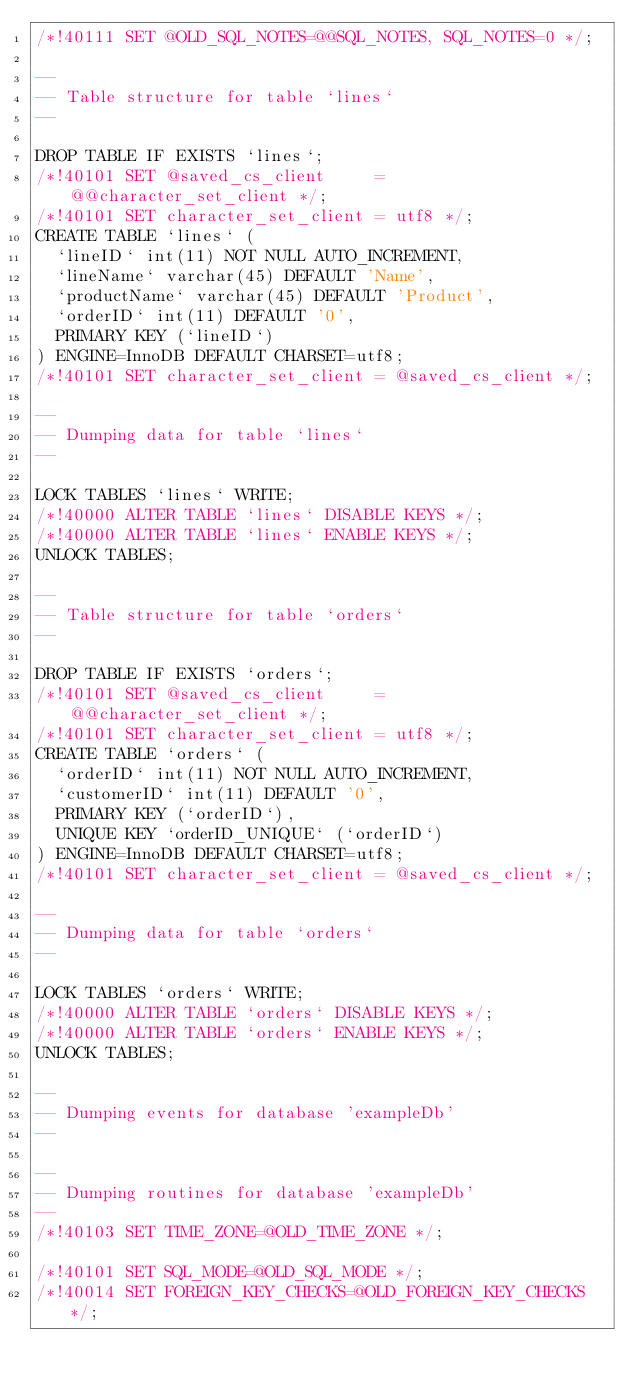Convert code to text. <code><loc_0><loc_0><loc_500><loc_500><_SQL_>/*!40111 SET @OLD_SQL_NOTES=@@SQL_NOTES, SQL_NOTES=0 */;

--
-- Table structure for table `lines`
--

DROP TABLE IF EXISTS `lines`;
/*!40101 SET @saved_cs_client     = @@character_set_client */;
/*!40101 SET character_set_client = utf8 */;
CREATE TABLE `lines` (
  `lineID` int(11) NOT NULL AUTO_INCREMENT,
  `lineName` varchar(45) DEFAULT 'Name',
  `productName` varchar(45) DEFAULT 'Product',
  `orderID` int(11) DEFAULT '0',
  PRIMARY KEY (`lineID`)
) ENGINE=InnoDB DEFAULT CHARSET=utf8;
/*!40101 SET character_set_client = @saved_cs_client */;

--
-- Dumping data for table `lines`
--

LOCK TABLES `lines` WRITE;
/*!40000 ALTER TABLE `lines` DISABLE KEYS */;
/*!40000 ALTER TABLE `lines` ENABLE KEYS */;
UNLOCK TABLES;

--
-- Table structure for table `orders`
--

DROP TABLE IF EXISTS `orders`;
/*!40101 SET @saved_cs_client     = @@character_set_client */;
/*!40101 SET character_set_client = utf8 */;
CREATE TABLE `orders` (
  `orderID` int(11) NOT NULL AUTO_INCREMENT,
  `customerID` int(11) DEFAULT '0',
  PRIMARY KEY (`orderID`),
  UNIQUE KEY `orderID_UNIQUE` (`orderID`)
) ENGINE=InnoDB DEFAULT CHARSET=utf8;
/*!40101 SET character_set_client = @saved_cs_client */;

--
-- Dumping data for table `orders`
--

LOCK TABLES `orders` WRITE;
/*!40000 ALTER TABLE `orders` DISABLE KEYS */;
/*!40000 ALTER TABLE `orders` ENABLE KEYS */;
UNLOCK TABLES;

--
-- Dumping events for database 'exampleDb'
--

--
-- Dumping routines for database 'exampleDb'
--
/*!40103 SET TIME_ZONE=@OLD_TIME_ZONE */;

/*!40101 SET SQL_MODE=@OLD_SQL_MODE */;
/*!40014 SET FOREIGN_KEY_CHECKS=@OLD_FOREIGN_KEY_CHECKS */;</code> 